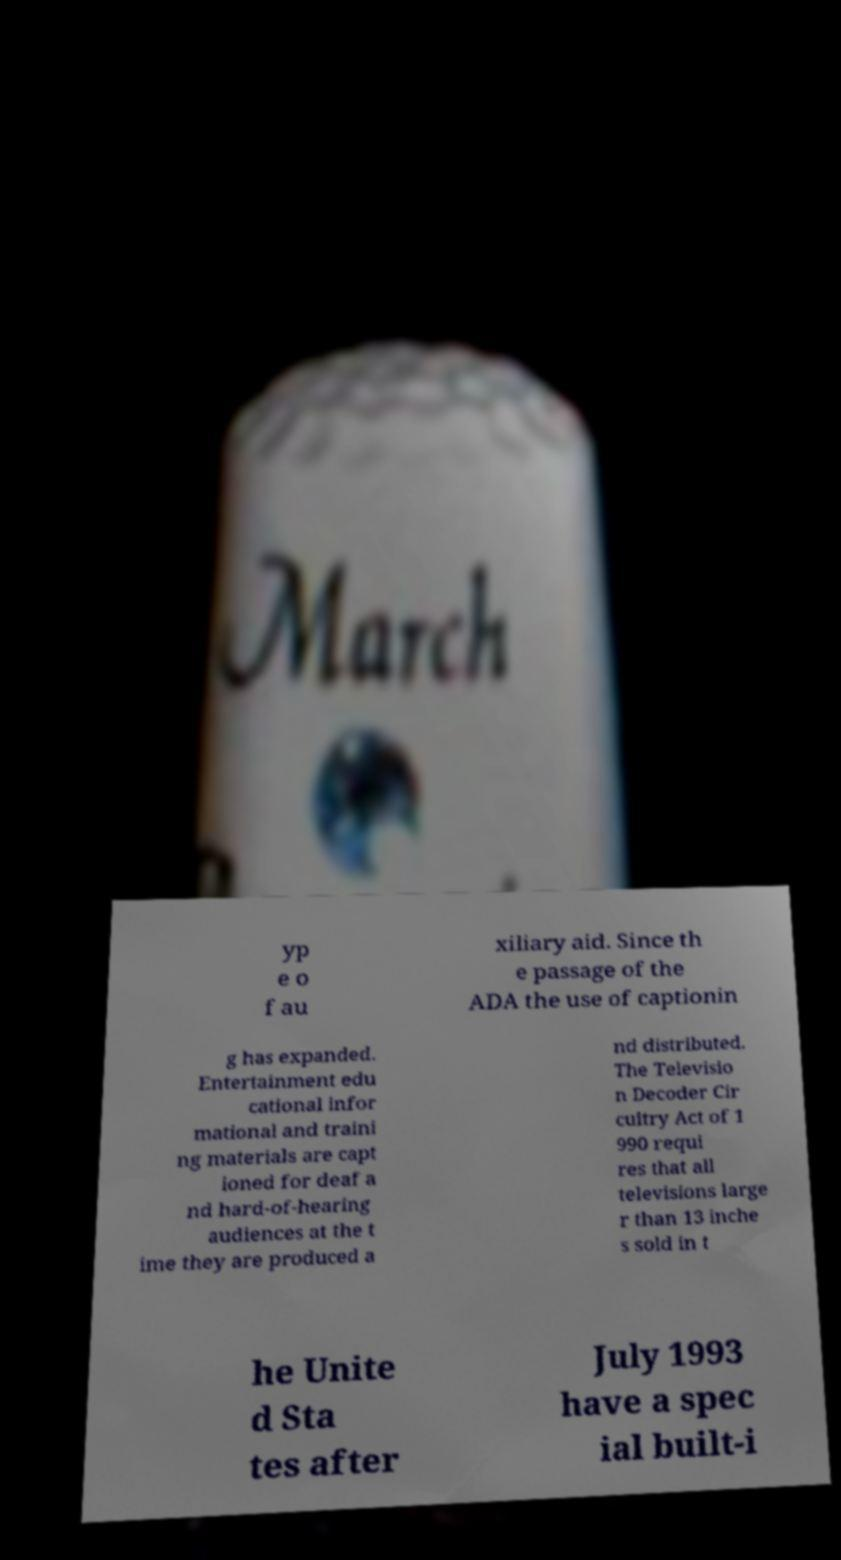For documentation purposes, I need the text within this image transcribed. Could you provide that? yp e o f au xiliary aid. Since th e passage of the ADA the use of captionin g has expanded. Entertainment edu cational infor mational and traini ng materials are capt ioned for deaf a nd hard-of-hearing audiences at the t ime they are produced a nd distributed. The Televisio n Decoder Cir cuitry Act of 1 990 requi res that all televisions large r than 13 inche s sold in t he Unite d Sta tes after July 1993 have a spec ial built-i 